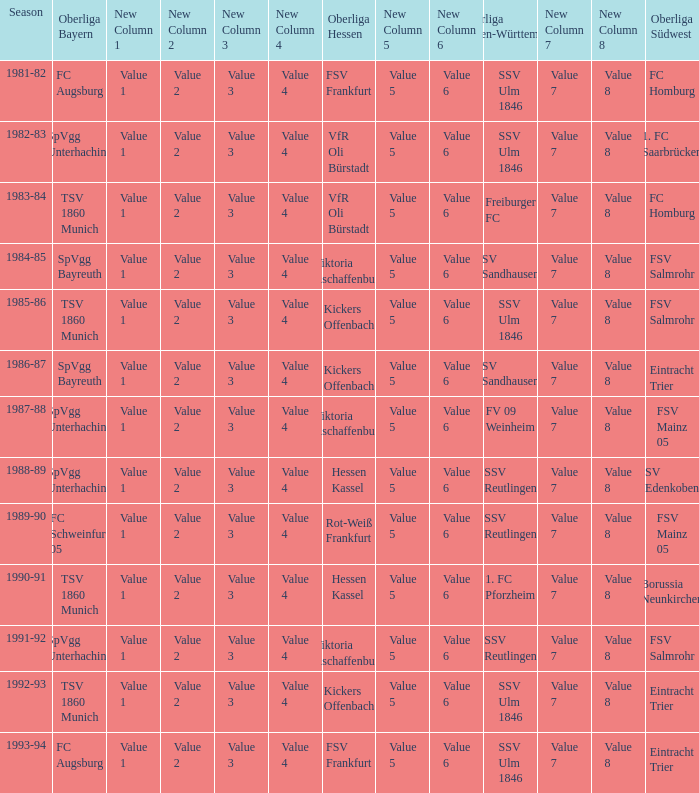Which oberliga südwes has an oberliga baden-württemberg of sv sandhausen in 1984-85? FSV Salmrohr. 